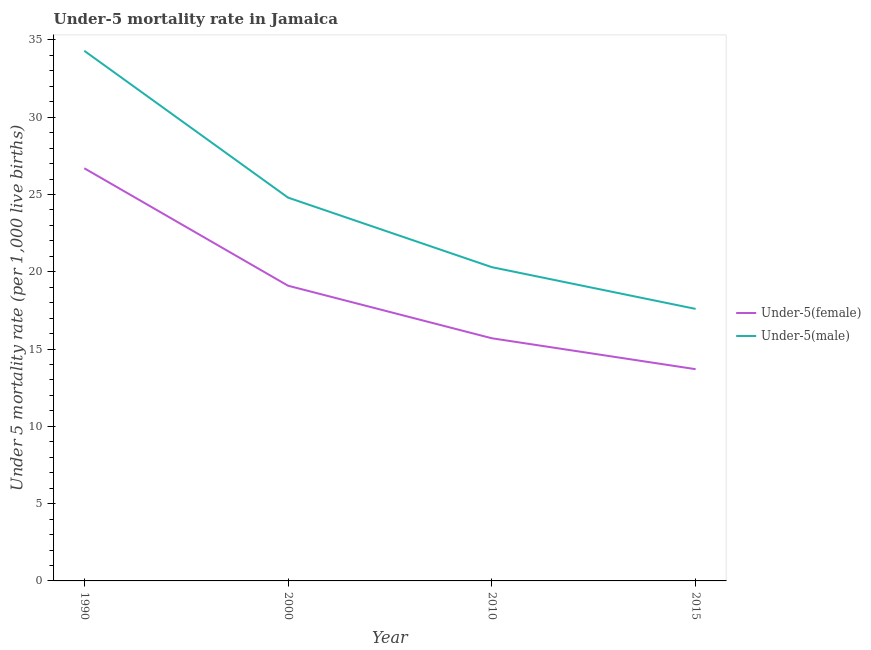Is the number of lines equal to the number of legend labels?
Your answer should be compact. Yes. Across all years, what is the maximum under-5 female mortality rate?
Make the answer very short. 26.7. Across all years, what is the minimum under-5 male mortality rate?
Offer a very short reply. 17.6. In which year was the under-5 female mortality rate minimum?
Offer a terse response. 2015. What is the total under-5 male mortality rate in the graph?
Provide a short and direct response. 97. What is the difference between the under-5 male mortality rate in 1990 and that in 2015?
Make the answer very short. 16.7. What is the difference between the under-5 male mortality rate in 2015 and the under-5 female mortality rate in 2010?
Give a very brief answer. 1.9. What is the average under-5 female mortality rate per year?
Provide a short and direct response. 18.8. In the year 2015, what is the difference between the under-5 male mortality rate and under-5 female mortality rate?
Keep it short and to the point. 3.9. In how many years, is the under-5 female mortality rate greater than 24?
Your answer should be very brief. 1. What is the ratio of the under-5 female mortality rate in 1990 to that in 2015?
Your response must be concise. 1.95. Is the difference between the under-5 male mortality rate in 1990 and 2000 greater than the difference between the under-5 female mortality rate in 1990 and 2000?
Make the answer very short. Yes. What is the difference between the highest and the second highest under-5 male mortality rate?
Your response must be concise. 9.5. Is the sum of the under-5 female mortality rate in 1990 and 2015 greater than the maximum under-5 male mortality rate across all years?
Your answer should be compact. Yes. How many years are there in the graph?
Your answer should be compact. 4. Are the values on the major ticks of Y-axis written in scientific E-notation?
Your answer should be very brief. No. Does the graph contain grids?
Make the answer very short. No. Where does the legend appear in the graph?
Your answer should be compact. Center right. What is the title of the graph?
Make the answer very short. Under-5 mortality rate in Jamaica. Does "Unregistered firms" appear as one of the legend labels in the graph?
Offer a terse response. No. What is the label or title of the X-axis?
Provide a succinct answer. Year. What is the label or title of the Y-axis?
Offer a terse response. Under 5 mortality rate (per 1,0 live births). What is the Under 5 mortality rate (per 1,000 live births) in Under-5(female) in 1990?
Offer a terse response. 26.7. What is the Under 5 mortality rate (per 1,000 live births) of Under-5(male) in 1990?
Make the answer very short. 34.3. What is the Under 5 mortality rate (per 1,000 live births) in Under-5(female) in 2000?
Ensure brevity in your answer.  19.1. What is the Under 5 mortality rate (per 1,000 live births) of Under-5(male) in 2000?
Offer a terse response. 24.8. What is the Under 5 mortality rate (per 1,000 live births) in Under-5(female) in 2010?
Ensure brevity in your answer.  15.7. What is the Under 5 mortality rate (per 1,000 live births) of Under-5(male) in 2010?
Offer a very short reply. 20.3. What is the Under 5 mortality rate (per 1,000 live births) in Under-5(female) in 2015?
Your answer should be compact. 13.7. What is the Under 5 mortality rate (per 1,000 live births) of Under-5(male) in 2015?
Your response must be concise. 17.6. Across all years, what is the maximum Under 5 mortality rate (per 1,000 live births) of Under-5(female)?
Provide a short and direct response. 26.7. Across all years, what is the maximum Under 5 mortality rate (per 1,000 live births) in Under-5(male)?
Make the answer very short. 34.3. What is the total Under 5 mortality rate (per 1,000 live births) in Under-5(female) in the graph?
Ensure brevity in your answer.  75.2. What is the total Under 5 mortality rate (per 1,000 live births) in Under-5(male) in the graph?
Keep it short and to the point. 97. What is the difference between the Under 5 mortality rate (per 1,000 live births) in Under-5(male) in 1990 and that in 2000?
Provide a succinct answer. 9.5. What is the difference between the Under 5 mortality rate (per 1,000 live births) in Under-5(female) in 1990 and that in 2010?
Offer a terse response. 11. What is the difference between the Under 5 mortality rate (per 1,000 live births) of Under-5(male) in 1990 and that in 2015?
Give a very brief answer. 16.7. What is the difference between the Under 5 mortality rate (per 1,000 live births) in Under-5(female) in 2010 and that in 2015?
Make the answer very short. 2. What is the difference between the Under 5 mortality rate (per 1,000 live births) in Under-5(male) in 2010 and that in 2015?
Your response must be concise. 2.7. What is the difference between the Under 5 mortality rate (per 1,000 live births) in Under-5(female) in 1990 and the Under 5 mortality rate (per 1,000 live births) in Under-5(male) in 2000?
Give a very brief answer. 1.9. What is the difference between the Under 5 mortality rate (per 1,000 live births) in Under-5(female) in 1990 and the Under 5 mortality rate (per 1,000 live births) in Under-5(male) in 2010?
Your response must be concise. 6.4. What is the difference between the Under 5 mortality rate (per 1,000 live births) in Under-5(female) in 1990 and the Under 5 mortality rate (per 1,000 live births) in Under-5(male) in 2015?
Your answer should be very brief. 9.1. What is the difference between the Under 5 mortality rate (per 1,000 live births) of Under-5(female) in 2000 and the Under 5 mortality rate (per 1,000 live births) of Under-5(male) in 2010?
Make the answer very short. -1.2. What is the difference between the Under 5 mortality rate (per 1,000 live births) in Under-5(female) in 2000 and the Under 5 mortality rate (per 1,000 live births) in Under-5(male) in 2015?
Ensure brevity in your answer.  1.5. What is the average Under 5 mortality rate (per 1,000 live births) in Under-5(male) per year?
Offer a very short reply. 24.25. In the year 1990, what is the difference between the Under 5 mortality rate (per 1,000 live births) in Under-5(female) and Under 5 mortality rate (per 1,000 live births) in Under-5(male)?
Provide a short and direct response. -7.6. In the year 2000, what is the difference between the Under 5 mortality rate (per 1,000 live births) in Under-5(female) and Under 5 mortality rate (per 1,000 live births) in Under-5(male)?
Your answer should be compact. -5.7. What is the ratio of the Under 5 mortality rate (per 1,000 live births) in Under-5(female) in 1990 to that in 2000?
Make the answer very short. 1.4. What is the ratio of the Under 5 mortality rate (per 1,000 live births) of Under-5(male) in 1990 to that in 2000?
Your response must be concise. 1.38. What is the ratio of the Under 5 mortality rate (per 1,000 live births) of Under-5(female) in 1990 to that in 2010?
Keep it short and to the point. 1.7. What is the ratio of the Under 5 mortality rate (per 1,000 live births) in Under-5(male) in 1990 to that in 2010?
Make the answer very short. 1.69. What is the ratio of the Under 5 mortality rate (per 1,000 live births) in Under-5(female) in 1990 to that in 2015?
Your answer should be very brief. 1.95. What is the ratio of the Under 5 mortality rate (per 1,000 live births) in Under-5(male) in 1990 to that in 2015?
Offer a very short reply. 1.95. What is the ratio of the Under 5 mortality rate (per 1,000 live births) of Under-5(female) in 2000 to that in 2010?
Provide a short and direct response. 1.22. What is the ratio of the Under 5 mortality rate (per 1,000 live births) in Under-5(male) in 2000 to that in 2010?
Offer a very short reply. 1.22. What is the ratio of the Under 5 mortality rate (per 1,000 live births) of Under-5(female) in 2000 to that in 2015?
Your response must be concise. 1.39. What is the ratio of the Under 5 mortality rate (per 1,000 live births) of Under-5(male) in 2000 to that in 2015?
Provide a short and direct response. 1.41. What is the ratio of the Under 5 mortality rate (per 1,000 live births) in Under-5(female) in 2010 to that in 2015?
Your answer should be very brief. 1.15. What is the ratio of the Under 5 mortality rate (per 1,000 live births) of Under-5(male) in 2010 to that in 2015?
Offer a very short reply. 1.15. What is the difference between the highest and the lowest Under 5 mortality rate (per 1,000 live births) of Under-5(female)?
Provide a succinct answer. 13. What is the difference between the highest and the lowest Under 5 mortality rate (per 1,000 live births) of Under-5(male)?
Offer a very short reply. 16.7. 